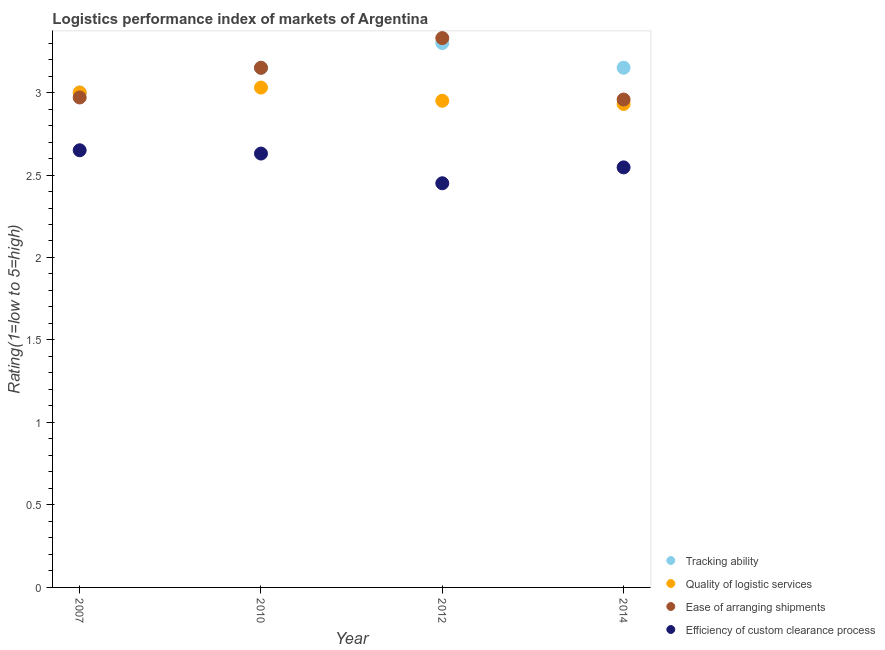Is the number of dotlines equal to the number of legend labels?
Your answer should be very brief. Yes. Across all years, what is the maximum lpi rating of quality of logistic services?
Your response must be concise. 3.03. Across all years, what is the minimum lpi rating of ease of arranging shipments?
Keep it short and to the point. 2.96. In which year was the lpi rating of ease of arranging shipments maximum?
Give a very brief answer. 2012. What is the total lpi rating of ease of arranging shipments in the graph?
Make the answer very short. 12.41. What is the difference between the lpi rating of tracking ability in 2007 and that in 2014?
Ensure brevity in your answer.  -0.15. What is the difference between the lpi rating of tracking ability in 2007 and the lpi rating of quality of logistic services in 2010?
Offer a terse response. -0.03. What is the average lpi rating of tracking ability per year?
Offer a terse response. 3.15. In the year 2007, what is the difference between the lpi rating of ease of arranging shipments and lpi rating of efficiency of custom clearance process?
Provide a short and direct response. 0.32. What is the ratio of the lpi rating of efficiency of custom clearance process in 2010 to that in 2012?
Provide a short and direct response. 1.07. What is the difference between the highest and the second highest lpi rating of ease of arranging shipments?
Keep it short and to the point. 0.18. What is the difference between the highest and the lowest lpi rating of quality of logistic services?
Keep it short and to the point. 0.1. In how many years, is the lpi rating of quality of logistic services greater than the average lpi rating of quality of logistic services taken over all years?
Your answer should be compact. 2. Is it the case that in every year, the sum of the lpi rating of tracking ability and lpi rating of efficiency of custom clearance process is greater than the sum of lpi rating of ease of arranging shipments and lpi rating of quality of logistic services?
Keep it short and to the point. No. Is it the case that in every year, the sum of the lpi rating of tracking ability and lpi rating of quality of logistic services is greater than the lpi rating of ease of arranging shipments?
Ensure brevity in your answer.  Yes. Does the lpi rating of efficiency of custom clearance process monotonically increase over the years?
Make the answer very short. No. Is the lpi rating of quality of logistic services strictly greater than the lpi rating of ease of arranging shipments over the years?
Offer a very short reply. No. Is the lpi rating of quality of logistic services strictly less than the lpi rating of efficiency of custom clearance process over the years?
Provide a succinct answer. No. Are the values on the major ticks of Y-axis written in scientific E-notation?
Provide a short and direct response. No. Does the graph contain any zero values?
Your response must be concise. No. Where does the legend appear in the graph?
Give a very brief answer. Bottom right. What is the title of the graph?
Offer a terse response. Logistics performance index of markets of Argentina. Does "First 20% of population" appear as one of the legend labels in the graph?
Your answer should be compact. No. What is the label or title of the Y-axis?
Make the answer very short. Rating(1=low to 5=high). What is the Rating(1=low to 5=high) of Ease of arranging shipments in 2007?
Provide a short and direct response. 2.97. What is the Rating(1=low to 5=high) in Efficiency of custom clearance process in 2007?
Make the answer very short. 2.65. What is the Rating(1=low to 5=high) of Tracking ability in 2010?
Offer a very short reply. 3.15. What is the Rating(1=low to 5=high) in Quality of logistic services in 2010?
Ensure brevity in your answer.  3.03. What is the Rating(1=low to 5=high) of Ease of arranging shipments in 2010?
Your answer should be very brief. 3.15. What is the Rating(1=low to 5=high) in Efficiency of custom clearance process in 2010?
Give a very brief answer. 2.63. What is the Rating(1=low to 5=high) in Tracking ability in 2012?
Give a very brief answer. 3.3. What is the Rating(1=low to 5=high) in Quality of logistic services in 2012?
Offer a terse response. 2.95. What is the Rating(1=low to 5=high) of Ease of arranging shipments in 2012?
Your response must be concise. 3.33. What is the Rating(1=low to 5=high) in Efficiency of custom clearance process in 2012?
Your answer should be compact. 2.45. What is the Rating(1=low to 5=high) in Tracking ability in 2014?
Your answer should be very brief. 3.15. What is the Rating(1=low to 5=high) in Quality of logistic services in 2014?
Your response must be concise. 2.93. What is the Rating(1=low to 5=high) in Ease of arranging shipments in 2014?
Provide a succinct answer. 2.96. What is the Rating(1=low to 5=high) of Efficiency of custom clearance process in 2014?
Your answer should be compact. 2.55. Across all years, what is the maximum Rating(1=low to 5=high) in Tracking ability?
Your response must be concise. 3.3. Across all years, what is the maximum Rating(1=low to 5=high) in Quality of logistic services?
Provide a short and direct response. 3.03. Across all years, what is the maximum Rating(1=low to 5=high) of Ease of arranging shipments?
Provide a succinct answer. 3.33. Across all years, what is the maximum Rating(1=low to 5=high) of Efficiency of custom clearance process?
Provide a succinct answer. 2.65. Across all years, what is the minimum Rating(1=low to 5=high) in Tracking ability?
Your answer should be compact. 3. Across all years, what is the minimum Rating(1=low to 5=high) in Quality of logistic services?
Your answer should be very brief. 2.93. Across all years, what is the minimum Rating(1=low to 5=high) in Ease of arranging shipments?
Offer a very short reply. 2.96. Across all years, what is the minimum Rating(1=low to 5=high) in Efficiency of custom clearance process?
Provide a succinct answer. 2.45. What is the total Rating(1=low to 5=high) in Tracking ability in the graph?
Give a very brief answer. 12.6. What is the total Rating(1=low to 5=high) in Quality of logistic services in the graph?
Your answer should be very brief. 11.91. What is the total Rating(1=low to 5=high) in Ease of arranging shipments in the graph?
Your answer should be very brief. 12.41. What is the total Rating(1=low to 5=high) in Efficiency of custom clearance process in the graph?
Your answer should be compact. 10.28. What is the difference between the Rating(1=low to 5=high) in Quality of logistic services in 2007 and that in 2010?
Your answer should be compact. -0.03. What is the difference between the Rating(1=low to 5=high) in Ease of arranging shipments in 2007 and that in 2010?
Your answer should be very brief. -0.18. What is the difference between the Rating(1=low to 5=high) in Efficiency of custom clearance process in 2007 and that in 2010?
Your answer should be compact. 0.02. What is the difference between the Rating(1=low to 5=high) of Quality of logistic services in 2007 and that in 2012?
Your answer should be very brief. 0.05. What is the difference between the Rating(1=low to 5=high) in Ease of arranging shipments in 2007 and that in 2012?
Make the answer very short. -0.36. What is the difference between the Rating(1=low to 5=high) of Tracking ability in 2007 and that in 2014?
Make the answer very short. -0.15. What is the difference between the Rating(1=low to 5=high) in Quality of logistic services in 2007 and that in 2014?
Your answer should be very brief. 0.07. What is the difference between the Rating(1=low to 5=high) in Ease of arranging shipments in 2007 and that in 2014?
Ensure brevity in your answer.  0.01. What is the difference between the Rating(1=low to 5=high) of Efficiency of custom clearance process in 2007 and that in 2014?
Provide a succinct answer. 0.1. What is the difference between the Rating(1=low to 5=high) in Ease of arranging shipments in 2010 and that in 2012?
Give a very brief answer. -0.18. What is the difference between the Rating(1=low to 5=high) of Efficiency of custom clearance process in 2010 and that in 2012?
Give a very brief answer. 0.18. What is the difference between the Rating(1=low to 5=high) in Tracking ability in 2010 and that in 2014?
Offer a terse response. -0. What is the difference between the Rating(1=low to 5=high) of Quality of logistic services in 2010 and that in 2014?
Your response must be concise. 0.1. What is the difference between the Rating(1=low to 5=high) of Ease of arranging shipments in 2010 and that in 2014?
Offer a terse response. 0.19. What is the difference between the Rating(1=low to 5=high) in Efficiency of custom clearance process in 2010 and that in 2014?
Your response must be concise. 0.08. What is the difference between the Rating(1=low to 5=high) in Tracking ability in 2012 and that in 2014?
Provide a short and direct response. 0.15. What is the difference between the Rating(1=low to 5=high) of Quality of logistic services in 2012 and that in 2014?
Make the answer very short. 0.02. What is the difference between the Rating(1=low to 5=high) in Ease of arranging shipments in 2012 and that in 2014?
Give a very brief answer. 0.37. What is the difference between the Rating(1=low to 5=high) in Efficiency of custom clearance process in 2012 and that in 2014?
Offer a very short reply. -0.1. What is the difference between the Rating(1=low to 5=high) of Tracking ability in 2007 and the Rating(1=low to 5=high) of Quality of logistic services in 2010?
Your answer should be very brief. -0.03. What is the difference between the Rating(1=low to 5=high) of Tracking ability in 2007 and the Rating(1=low to 5=high) of Efficiency of custom clearance process in 2010?
Your answer should be compact. 0.37. What is the difference between the Rating(1=low to 5=high) in Quality of logistic services in 2007 and the Rating(1=low to 5=high) in Ease of arranging shipments in 2010?
Offer a very short reply. -0.15. What is the difference between the Rating(1=low to 5=high) of Quality of logistic services in 2007 and the Rating(1=low to 5=high) of Efficiency of custom clearance process in 2010?
Your answer should be compact. 0.37. What is the difference between the Rating(1=low to 5=high) of Ease of arranging shipments in 2007 and the Rating(1=low to 5=high) of Efficiency of custom clearance process in 2010?
Provide a succinct answer. 0.34. What is the difference between the Rating(1=low to 5=high) in Tracking ability in 2007 and the Rating(1=low to 5=high) in Ease of arranging shipments in 2012?
Make the answer very short. -0.33. What is the difference between the Rating(1=low to 5=high) in Tracking ability in 2007 and the Rating(1=low to 5=high) in Efficiency of custom clearance process in 2012?
Make the answer very short. 0.55. What is the difference between the Rating(1=low to 5=high) in Quality of logistic services in 2007 and the Rating(1=low to 5=high) in Ease of arranging shipments in 2012?
Your response must be concise. -0.33. What is the difference between the Rating(1=low to 5=high) of Quality of logistic services in 2007 and the Rating(1=low to 5=high) of Efficiency of custom clearance process in 2012?
Ensure brevity in your answer.  0.55. What is the difference between the Rating(1=low to 5=high) of Ease of arranging shipments in 2007 and the Rating(1=low to 5=high) of Efficiency of custom clearance process in 2012?
Ensure brevity in your answer.  0.52. What is the difference between the Rating(1=low to 5=high) in Tracking ability in 2007 and the Rating(1=low to 5=high) in Quality of logistic services in 2014?
Your response must be concise. 0.07. What is the difference between the Rating(1=low to 5=high) in Tracking ability in 2007 and the Rating(1=low to 5=high) in Ease of arranging shipments in 2014?
Offer a very short reply. 0.04. What is the difference between the Rating(1=low to 5=high) of Tracking ability in 2007 and the Rating(1=low to 5=high) of Efficiency of custom clearance process in 2014?
Your answer should be very brief. 0.45. What is the difference between the Rating(1=low to 5=high) in Quality of logistic services in 2007 and the Rating(1=low to 5=high) in Ease of arranging shipments in 2014?
Offer a terse response. 0.04. What is the difference between the Rating(1=low to 5=high) in Quality of logistic services in 2007 and the Rating(1=low to 5=high) in Efficiency of custom clearance process in 2014?
Give a very brief answer. 0.45. What is the difference between the Rating(1=low to 5=high) of Ease of arranging shipments in 2007 and the Rating(1=low to 5=high) of Efficiency of custom clearance process in 2014?
Provide a short and direct response. 0.42. What is the difference between the Rating(1=low to 5=high) of Tracking ability in 2010 and the Rating(1=low to 5=high) of Ease of arranging shipments in 2012?
Your response must be concise. -0.18. What is the difference between the Rating(1=low to 5=high) in Tracking ability in 2010 and the Rating(1=low to 5=high) in Efficiency of custom clearance process in 2012?
Offer a very short reply. 0.7. What is the difference between the Rating(1=low to 5=high) of Quality of logistic services in 2010 and the Rating(1=low to 5=high) of Ease of arranging shipments in 2012?
Your answer should be very brief. -0.3. What is the difference between the Rating(1=low to 5=high) in Quality of logistic services in 2010 and the Rating(1=low to 5=high) in Efficiency of custom clearance process in 2012?
Your response must be concise. 0.58. What is the difference between the Rating(1=low to 5=high) in Tracking ability in 2010 and the Rating(1=low to 5=high) in Quality of logistic services in 2014?
Provide a succinct answer. 0.22. What is the difference between the Rating(1=low to 5=high) of Tracking ability in 2010 and the Rating(1=low to 5=high) of Ease of arranging shipments in 2014?
Your response must be concise. 0.19. What is the difference between the Rating(1=low to 5=high) in Tracking ability in 2010 and the Rating(1=low to 5=high) in Efficiency of custom clearance process in 2014?
Offer a very short reply. 0.6. What is the difference between the Rating(1=low to 5=high) in Quality of logistic services in 2010 and the Rating(1=low to 5=high) in Ease of arranging shipments in 2014?
Keep it short and to the point. 0.07. What is the difference between the Rating(1=low to 5=high) of Quality of logistic services in 2010 and the Rating(1=low to 5=high) of Efficiency of custom clearance process in 2014?
Provide a short and direct response. 0.48. What is the difference between the Rating(1=low to 5=high) of Ease of arranging shipments in 2010 and the Rating(1=low to 5=high) of Efficiency of custom clearance process in 2014?
Your response must be concise. 0.6. What is the difference between the Rating(1=low to 5=high) in Tracking ability in 2012 and the Rating(1=low to 5=high) in Quality of logistic services in 2014?
Give a very brief answer. 0.37. What is the difference between the Rating(1=low to 5=high) in Tracking ability in 2012 and the Rating(1=low to 5=high) in Ease of arranging shipments in 2014?
Your answer should be very brief. 0.34. What is the difference between the Rating(1=low to 5=high) in Tracking ability in 2012 and the Rating(1=low to 5=high) in Efficiency of custom clearance process in 2014?
Your answer should be compact. 0.75. What is the difference between the Rating(1=low to 5=high) in Quality of logistic services in 2012 and the Rating(1=low to 5=high) in Ease of arranging shipments in 2014?
Offer a terse response. -0.01. What is the difference between the Rating(1=low to 5=high) in Quality of logistic services in 2012 and the Rating(1=low to 5=high) in Efficiency of custom clearance process in 2014?
Provide a succinct answer. 0.4. What is the difference between the Rating(1=low to 5=high) in Ease of arranging shipments in 2012 and the Rating(1=low to 5=high) in Efficiency of custom clearance process in 2014?
Your response must be concise. 0.78. What is the average Rating(1=low to 5=high) of Tracking ability per year?
Your answer should be very brief. 3.15. What is the average Rating(1=low to 5=high) in Quality of logistic services per year?
Ensure brevity in your answer.  2.98. What is the average Rating(1=low to 5=high) in Ease of arranging shipments per year?
Keep it short and to the point. 3.1. What is the average Rating(1=low to 5=high) of Efficiency of custom clearance process per year?
Ensure brevity in your answer.  2.57. In the year 2007, what is the difference between the Rating(1=low to 5=high) of Quality of logistic services and Rating(1=low to 5=high) of Ease of arranging shipments?
Your answer should be compact. 0.03. In the year 2007, what is the difference between the Rating(1=low to 5=high) in Quality of logistic services and Rating(1=low to 5=high) in Efficiency of custom clearance process?
Make the answer very short. 0.35. In the year 2007, what is the difference between the Rating(1=low to 5=high) in Ease of arranging shipments and Rating(1=low to 5=high) in Efficiency of custom clearance process?
Make the answer very short. 0.32. In the year 2010, what is the difference between the Rating(1=low to 5=high) in Tracking ability and Rating(1=low to 5=high) in Quality of logistic services?
Offer a very short reply. 0.12. In the year 2010, what is the difference between the Rating(1=low to 5=high) in Tracking ability and Rating(1=low to 5=high) in Efficiency of custom clearance process?
Ensure brevity in your answer.  0.52. In the year 2010, what is the difference between the Rating(1=low to 5=high) of Quality of logistic services and Rating(1=low to 5=high) of Ease of arranging shipments?
Offer a very short reply. -0.12. In the year 2010, what is the difference between the Rating(1=low to 5=high) of Ease of arranging shipments and Rating(1=low to 5=high) of Efficiency of custom clearance process?
Give a very brief answer. 0.52. In the year 2012, what is the difference between the Rating(1=low to 5=high) of Tracking ability and Rating(1=low to 5=high) of Ease of arranging shipments?
Offer a very short reply. -0.03. In the year 2012, what is the difference between the Rating(1=low to 5=high) in Tracking ability and Rating(1=low to 5=high) in Efficiency of custom clearance process?
Provide a short and direct response. 0.85. In the year 2012, what is the difference between the Rating(1=low to 5=high) in Quality of logistic services and Rating(1=low to 5=high) in Ease of arranging shipments?
Your answer should be very brief. -0.38. In the year 2012, what is the difference between the Rating(1=low to 5=high) of Quality of logistic services and Rating(1=low to 5=high) of Efficiency of custom clearance process?
Your answer should be compact. 0.5. In the year 2014, what is the difference between the Rating(1=low to 5=high) of Tracking ability and Rating(1=low to 5=high) of Quality of logistic services?
Your answer should be compact. 0.22. In the year 2014, what is the difference between the Rating(1=low to 5=high) of Tracking ability and Rating(1=low to 5=high) of Ease of arranging shipments?
Give a very brief answer. 0.19. In the year 2014, what is the difference between the Rating(1=low to 5=high) in Tracking ability and Rating(1=low to 5=high) in Efficiency of custom clearance process?
Ensure brevity in your answer.  0.6. In the year 2014, what is the difference between the Rating(1=low to 5=high) of Quality of logistic services and Rating(1=low to 5=high) of Ease of arranging shipments?
Your response must be concise. -0.03. In the year 2014, what is the difference between the Rating(1=low to 5=high) in Quality of logistic services and Rating(1=low to 5=high) in Efficiency of custom clearance process?
Keep it short and to the point. 0.38. In the year 2014, what is the difference between the Rating(1=low to 5=high) in Ease of arranging shipments and Rating(1=low to 5=high) in Efficiency of custom clearance process?
Make the answer very short. 0.41. What is the ratio of the Rating(1=low to 5=high) in Ease of arranging shipments in 2007 to that in 2010?
Keep it short and to the point. 0.94. What is the ratio of the Rating(1=low to 5=high) in Efficiency of custom clearance process in 2007 to that in 2010?
Make the answer very short. 1.01. What is the ratio of the Rating(1=low to 5=high) of Tracking ability in 2007 to that in 2012?
Make the answer very short. 0.91. What is the ratio of the Rating(1=low to 5=high) of Quality of logistic services in 2007 to that in 2012?
Ensure brevity in your answer.  1.02. What is the ratio of the Rating(1=low to 5=high) of Ease of arranging shipments in 2007 to that in 2012?
Your answer should be very brief. 0.89. What is the ratio of the Rating(1=low to 5=high) of Efficiency of custom clearance process in 2007 to that in 2012?
Provide a succinct answer. 1.08. What is the ratio of the Rating(1=low to 5=high) of Tracking ability in 2007 to that in 2014?
Ensure brevity in your answer.  0.95. What is the ratio of the Rating(1=low to 5=high) in Quality of logistic services in 2007 to that in 2014?
Your answer should be very brief. 1.02. What is the ratio of the Rating(1=low to 5=high) of Ease of arranging shipments in 2007 to that in 2014?
Your answer should be compact. 1. What is the ratio of the Rating(1=low to 5=high) of Efficiency of custom clearance process in 2007 to that in 2014?
Provide a succinct answer. 1.04. What is the ratio of the Rating(1=low to 5=high) of Tracking ability in 2010 to that in 2012?
Make the answer very short. 0.95. What is the ratio of the Rating(1=low to 5=high) in Quality of logistic services in 2010 to that in 2012?
Ensure brevity in your answer.  1.03. What is the ratio of the Rating(1=low to 5=high) of Ease of arranging shipments in 2010 to that in 2012?
Ensure brevity in your answer.  0.95. What is the ratio of the Rating(1=low to 5=high) in Efficiency of custom clearance process in 2010 to that in 2012?
Give a very brief answer. 1.07. What is the ratio of the Rating(1=low to 5=high) in Tracking ability in 2010 to that in 2014?
Your response must be concise. 1. What is the ratio of the Rating(1=low to 5=high) in Quality of logistic services in 2010 to that in 2014?
Offer a terse response. 1.03. What is the ratio of the Rating(1=low to 5=high) of Ease of arranging shipments in 2010 to that in 2014?
Offer a very short reply. 1.07. What is the ratio of the Rating(1=low to 5=high) in Efficiency of custom clearance process in 2010 to that in 2014?
Ensure brevity in your answer.  1.03. What is the ratio of the Rating(1=low to 5=high) of Tracking ability in 2012 to that in 2014?
Your response must be concise. 1.05. What is the ratio of the Rating(1=low to 5=high) of Quality of logistic services in 2012 to that in 2014?
Your answer should be compact. 1.01. What is the ratio of the Rating(1=low to 5=high) of Ease of arranging shipments in 2012 to that in 2014?
Keep it short and to the point. 1.13. What is the ratio of the Rating(1=low to 5=high) in Efficiency of custom clearance process in 2012 to that in 2014?
Make the answer very short. 0.96. What is the difference between the highest and the second highest Rating(1=low to 5=high) in Tracking ability?
Make the answer very short. 0.15. What is the difference between the highest and the second highest Rating(1=low to 5=high) in Quality of logistic services?
Make the answer very short. 0.03. What is the difference between the highest and the second highest Rating(1=low to 5=high) in Ease of arranging shipments?
Ensure brevity in your answer.  0.18. What is the difference between the highest and the lowest Rating(1=low to 5=high) in Tracking ability?
Keep it short and to the point. 0.3. What is the difference between the highest and the lowest Rating(1=low to 5=high) of Quality of logistic services?
Provide a succinct answer. 0.1. What is the difference between the highest and the lowest Rating(1=low to 5=high) in Ease of arranging shipments?
Offer a very short reply. 0.37. What is the difference between the highest and the lowest Rating(1=low to 5=high) in Efficiency of custom clearance process?
Your answer should be compact. 0.2. 